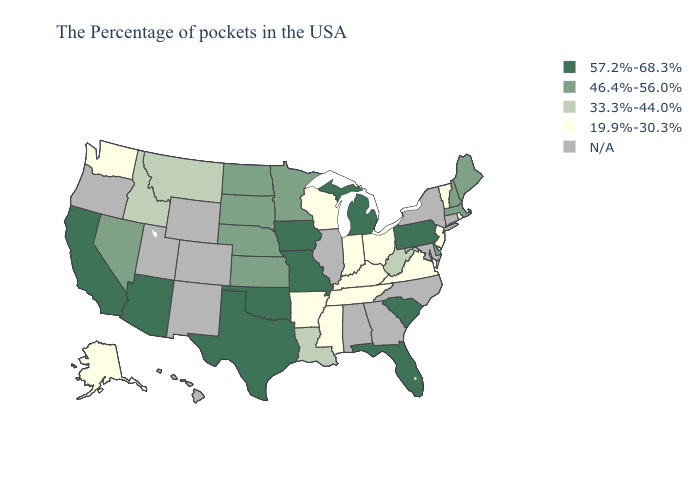Name the states that have a value in the range 46.4%-56.0%?
Quick response, please. Maine, Massachusetts, New Hampshire, Delaware, Minnesota, Kansas, Nebraska, South Dakota, North Dakota, Nevada. Name the states that have a value in the range 46.4%-56.0%?
Be succinct. Maine, Massachusetts, New Hampshire, Delaware, Minnesota, Kansas, Nebraska, South Dakota, North Dakota, Nevada. What is the highest value in the USA?
Answer briefly. 57.2%-68.3%. Is the legend a continuous bar?
Keep it brief. No. Among the states that border New Mexico , which have the highest value?
Quick response, please. Oklahoma, Texas, Arizona. Name the states that have a value in the range 46.4%-56.0%?
Answer briefly. Maine, Massachusetts, New Hampshire, Delaware, Minnesota, Kansas, Nebraska, South Dakota, North Dakota, Nevada. Name the states that have a value in the range 46.4%-56.0%?
Concise answer only. Maine, Massachusetts, New Hampshire, Delaware, Minnesota, Kansas, Nebraska, South Dakota, North Dakota, Nevada. What is the lowest value in the West?
Be succinct. 19.9%-30.3%. Among the states that border Tennessee , does Virginia have the lowest value?
Concise answer only. Yes. What is the highest value in states that border Illinois?
Be succinct. 57.2%-68.3%. What is the lowest value in states that border Idaho?
Short answer required. 19.9%-30.3%. What is the lowest value in the USA?
Short answer required. 19.9%-30.3%. Which states have the lowest value in the South?
Quick response, please. Virginia, Kentucky, Tennessee, Mississippi, Arkansas. Does Delaware have the lowest value in the South?
Write a very short answer. No. What is the lowest value in the USA?
Quick response, please. 19.9%-30.3%. 